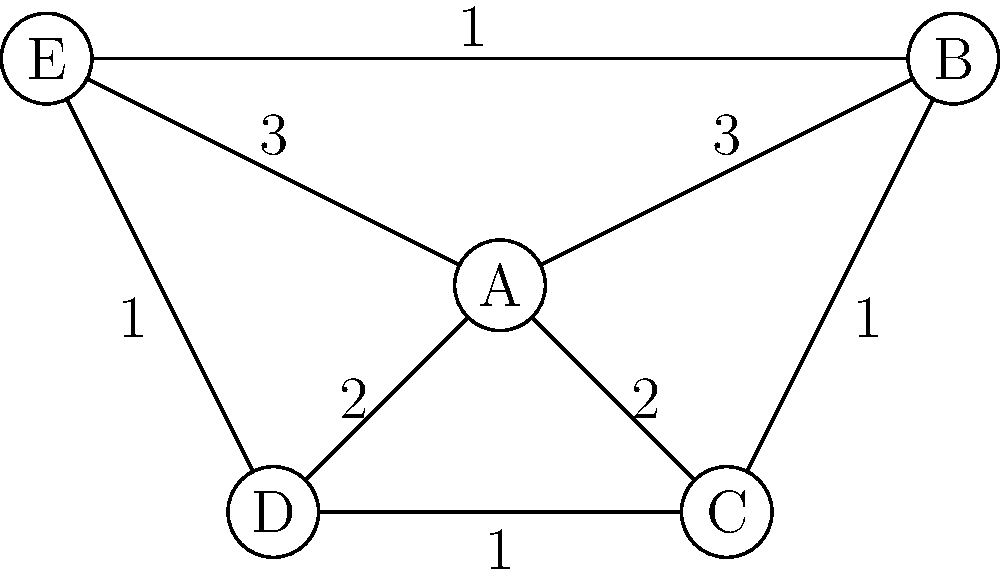In a distributed storage system for genomic information, nodes represent data centers, and edges represent data transfer capabilities between centers. The weight of each edge indicates the cost of data transfer (in hours). What is the minimum spanning tree's total weight for this network, ensuring optimal data redundancy while minimizing transfer costs? To find the minimum spanning tree (MST) for this network, we'll use Kruskal's algorithm, which is known for its efficiency and precision in identifying the MST. This approach aligns with the meticulous nature required in genetic research.

Step 1: Sort all edges by weight in ascending order:
1. B-C, C-D, D-E, E-B (all weight 1)
2. A-C, A-D (both weight 2)
3. A-B, A-E (both weight 3)

Step 2: Apply Kruskal's algorithm:
1. Add B-C (weight 1)
2. Add C-D (weight 1)
3. Add D-E (weight 1)
4. Skip E-B (creates a cycle)
5. Add A-C (weight 2)

At this point, we have connected all nodes with 4 edges, which is the requirement for a spanning tree in a 5-node graph.

Step 3: Calculate the total weight of the MST:
$$ \text{Total Weight} = 1 + 1 + 1 + 2 = 5 $$

This MST ensures that all data centers are connected with the minimum total transfer cost, optimizing data redundancy while maintaining stringent control over resource utilization.
Answer: 5 hours 